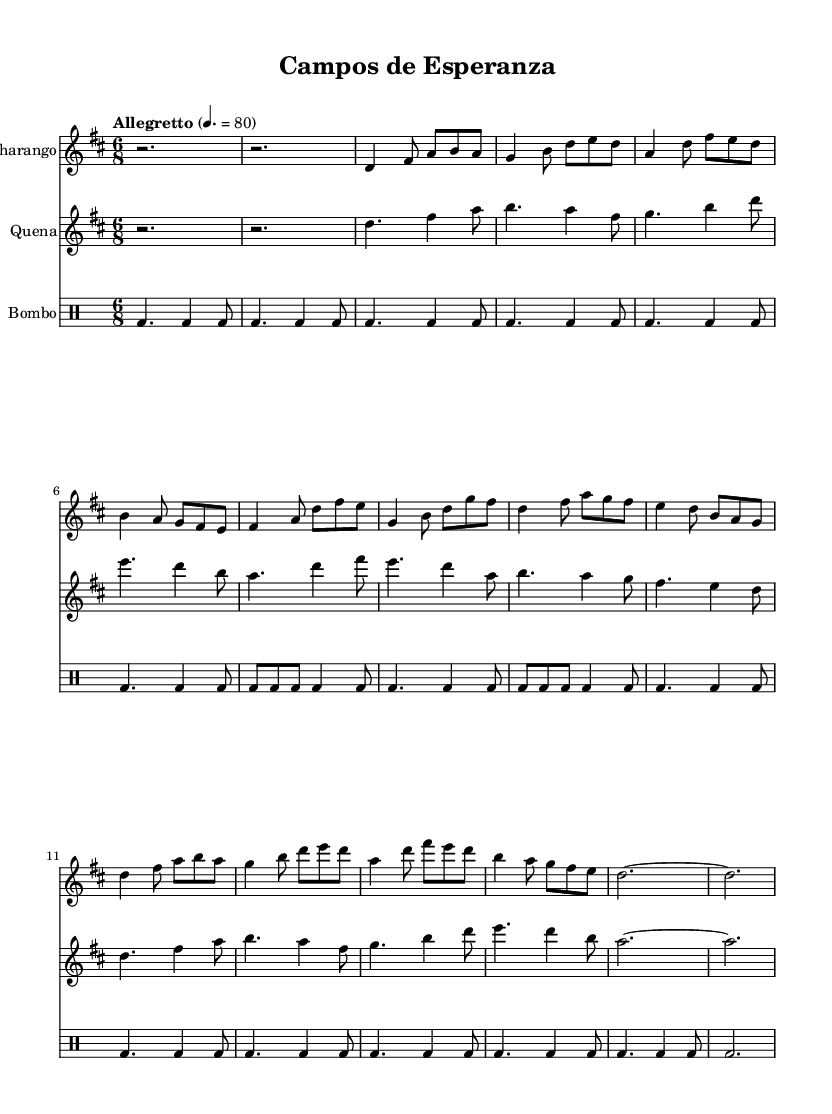What is the key signature of this music? The key signature is determined by the number of sharps or flats at the beginning of the staff. In this case, there are two sharps (F# and C#), indicating the key of D major.
Answer: D major What is the time signature of this music? The time signature is located after the key signature and denotes the beat structure of the music. In this sheet music, the time signature is 6/8, which means there are six eighth notes per measure.
Answer: 6/8 What is the tempo marking for this piece? The tempo marking is usually indicated at the beginning of the piece. In this sheet music, it specifies "Allegretto" at a metronome marking of 80 beats per minute.
Answer: Allegretto 80 How many sections are there in this piece? The piece is structured into distinct sections labeled A, B, and C, with section A being repeated twice. By counting the unique lettered sections, there are three main sections (A, B, and C).
Answer: Three Which instruments are featured in this score? The score lists distinct parts for specific instruments: Charango, Quena, and Bombo. This can be identified from the respective staff names at the beginning of each section.
Answer: Charango, Quena, Bombo In which section does the melody start? The melody begins in the A Section, where the first musical phrases are presented for the Charango and Quena parts. This can be identified as the first labeled section in the composition.
Answer: A Section What rhythmic pattern is primarily used for the Bombo? The rhythmic pattern primarily utilized for the Bombo is based on a steady beat, predominantly using quarter notes and eighth notes, which are represented in a repeated style throughout the sections.
Answer: Steady beat 